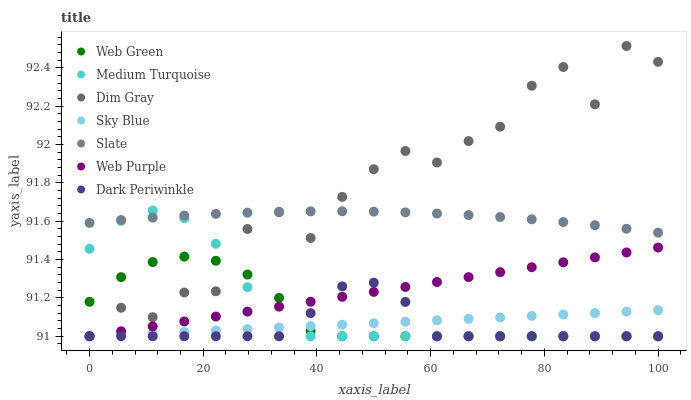Does Dark Periwinkle have the minimum area under the curve?
Answer yes or no. Yes. Does Dim Gray have the maximum area under the curve?
Answer yes or no. Yes. Does Slate have the minimum area under the curve?
Answer yes or no. No. Does Slate have the maximum area under the curve?
Answer yes or no. No. Is Sky Blue the smoothest?
Answer yes or no. Yes. Is Dim Gray the roughest?
Answer yes or no. Yes. Is Slate the smoothest?
Answer yes or no. No. Is Slate the roughest?
Answer yes or no. No. Does Dim Gray have the lowest value?
Answer yes or no. Yes. Does Slate have the lowest value?
Answer yes or no. No. Does Dim Gray have the highest value?
Answer yes or no. Yes. Does Slate have the highest value?
Answer yes or no. No. Is Web Purple less than Slate?
Answer yes or no. Yes. Is Slate greater than Web Green?
Answer yes or no. Yes. Does Web Purple intersect Dim Gray?
Answer yes or no. Yes. Is Web Purple less than Dim Gray?
Answer yes or no. No. Is Web Purple greater than Dim Gray?
Answer yes or no. No. Does Web Purple intersect Slate?
Answer yes or no. No. 